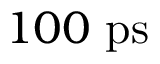Convert formula to latex. <formula><loc_0><loc_0><loc_500><loc_500>1 0 0 p s</formula> 